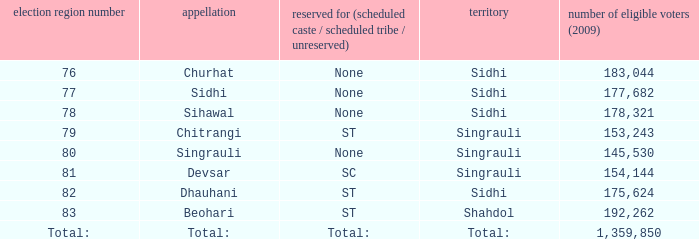What is Beohari's reserved for (SC/ST/None)? ST. 